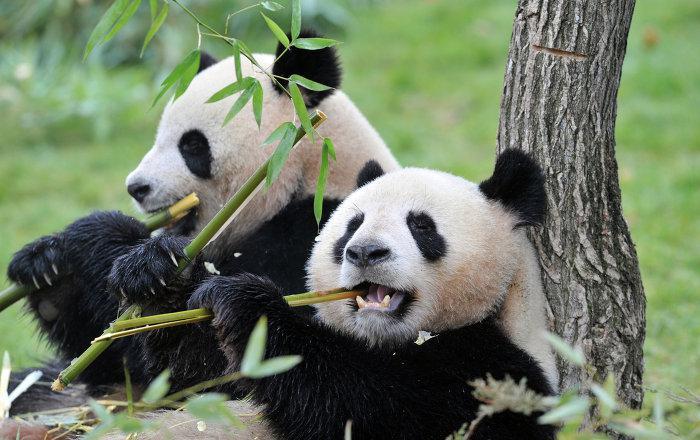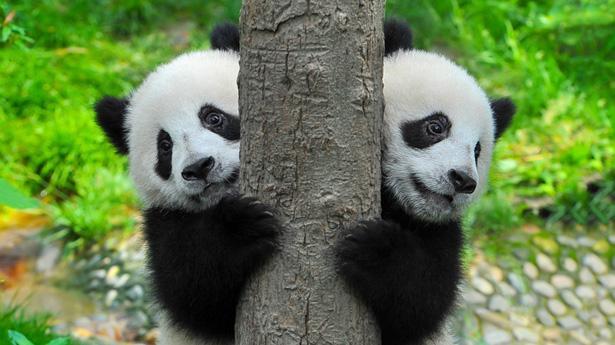The first image is the image on the left, the second image is the image on the right. Evaluate the accuracy of this statement regarding the images: "There are four pandas.". Is it true? Answer yes or no. Yes. The first image is the image on the left, the second image is the image on the right. Given the left and right images, does the statement "There are four pandas in the pair of images." hold true? Answer yes or no. Yes. 